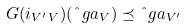Convert formula to latex. <formula><loc_0><loc_0><loc_500><loc_500>\ G ( i _ { V ^ { \prime } \, V } ) ( \hat { \ } g a _ { V } ) \preceq \hat { \ } g a _ { V ^ { \prime } }</formula> 